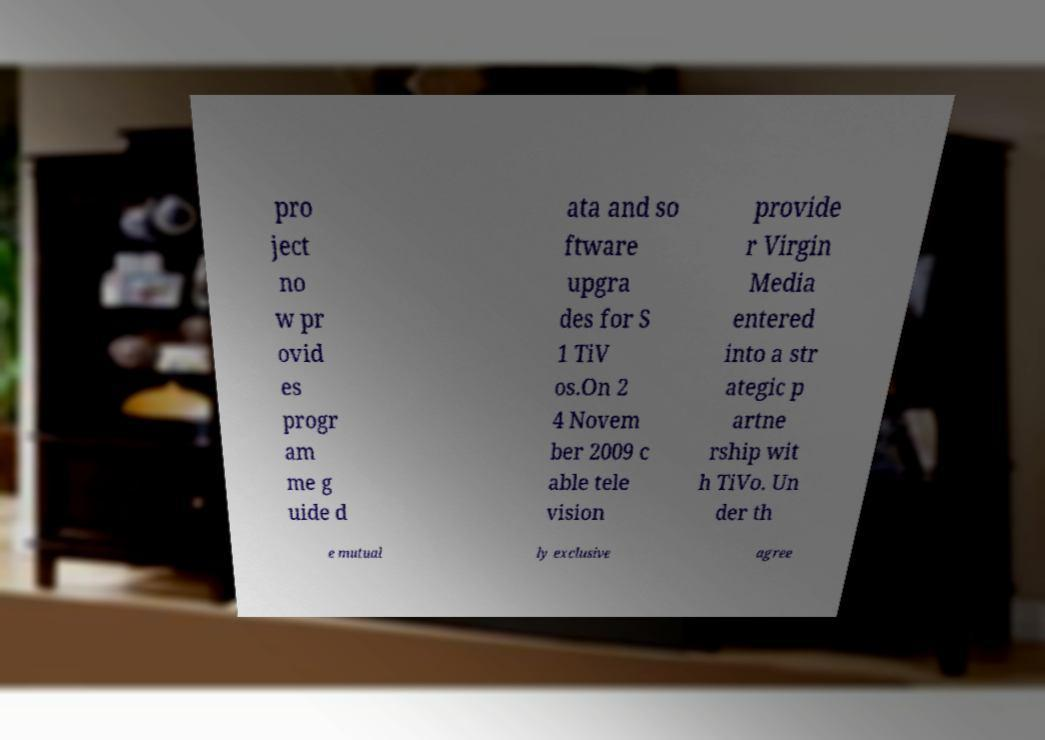Could you extract and type out the text from this image? pro ject no w pr ovid es progr am me g uide d ata and so ftware upgra des for S 1 TiV os.On 2 4 Novem ber 2009 c able tele vision provide r Virgin Media entered into a str ategic p artne rship wit h TiVo. Un der th e mutual ly exclusive agree 